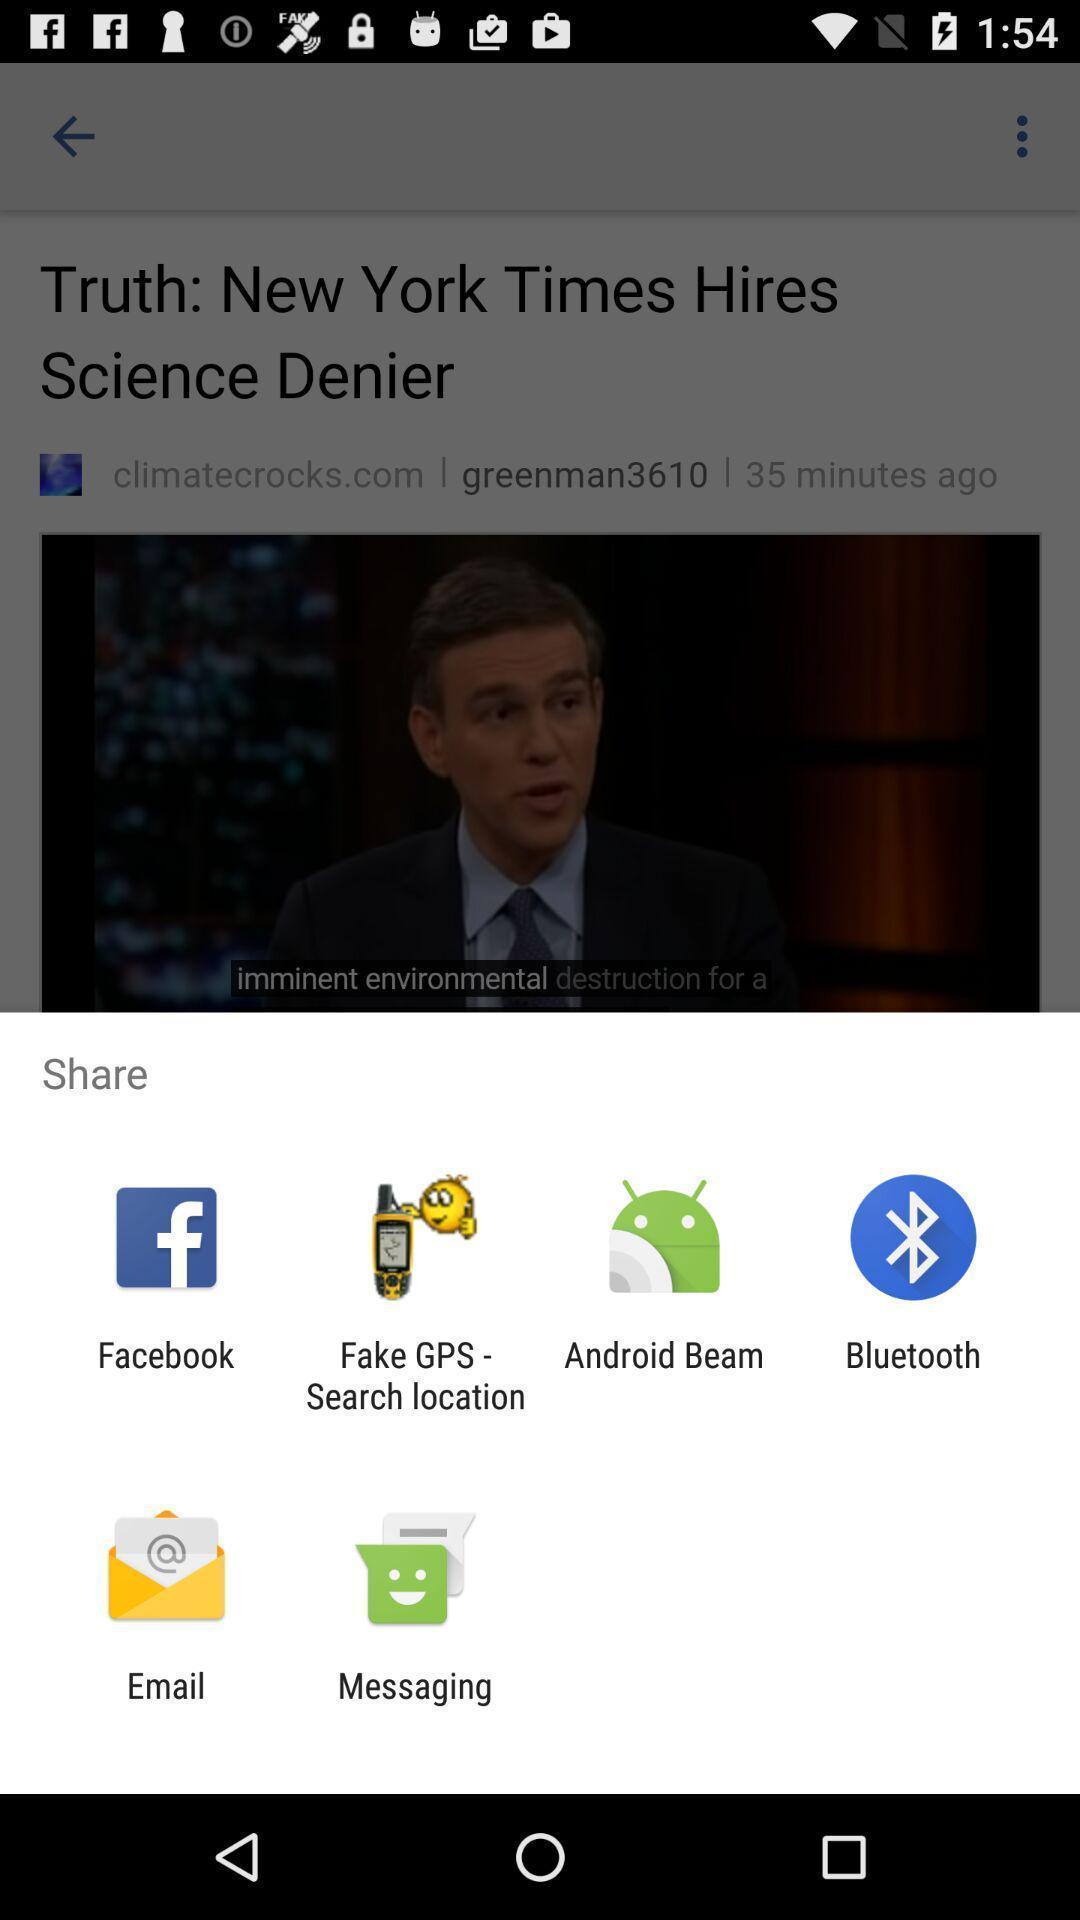Tell me about the visual elements in this screen capture. Share information with different apps. 